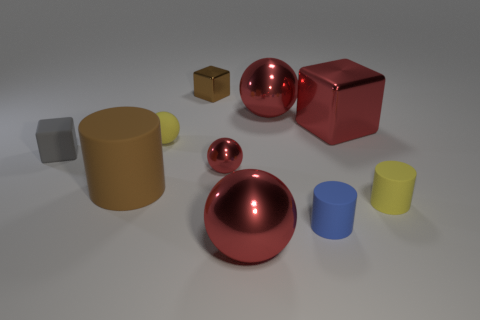There is a large block that is the same color as the small shiny ball; what material is it?
Give a very brief answer. Metal. What number of large red things have the same material as the tiny gray object?
Your response must be concise. 0. There is a tiny sphere that is made of the same material as the brown cylinder; what is its color?
Your response must be concise. Yellow. There is a metal ball that is to the left of the large ball that is in front of the big brown matte cylinder that is on the left side of the tiny yellow ball; what is its size?
Your answer should be compact. Small. Are there fewer purple spheres than big shiny objects?
Your response must be concise. Yes. There is another tiny rubber thing that is the same shape as the blue object; what is its color?
Keep it short and to the point. Yellow. Are there any brown metal cubes on the left side of the yellow object left of the large metallic ball in front of the large shiny cube?
Offer a very short reply. No. Is the tiny brown shiny thing the same shape as the gray object?
Your answer should be very brief. Yes. Are there fewer red shiny spheres in front of the tiny gray object than small gray metallic cylinders?
Make the answer very short. No. There is a small matte cylinder on the left side of the big red metal object on the right side of the big ball behind the big rubber thing; what color is it?
Offer a very short reply. Blue. 